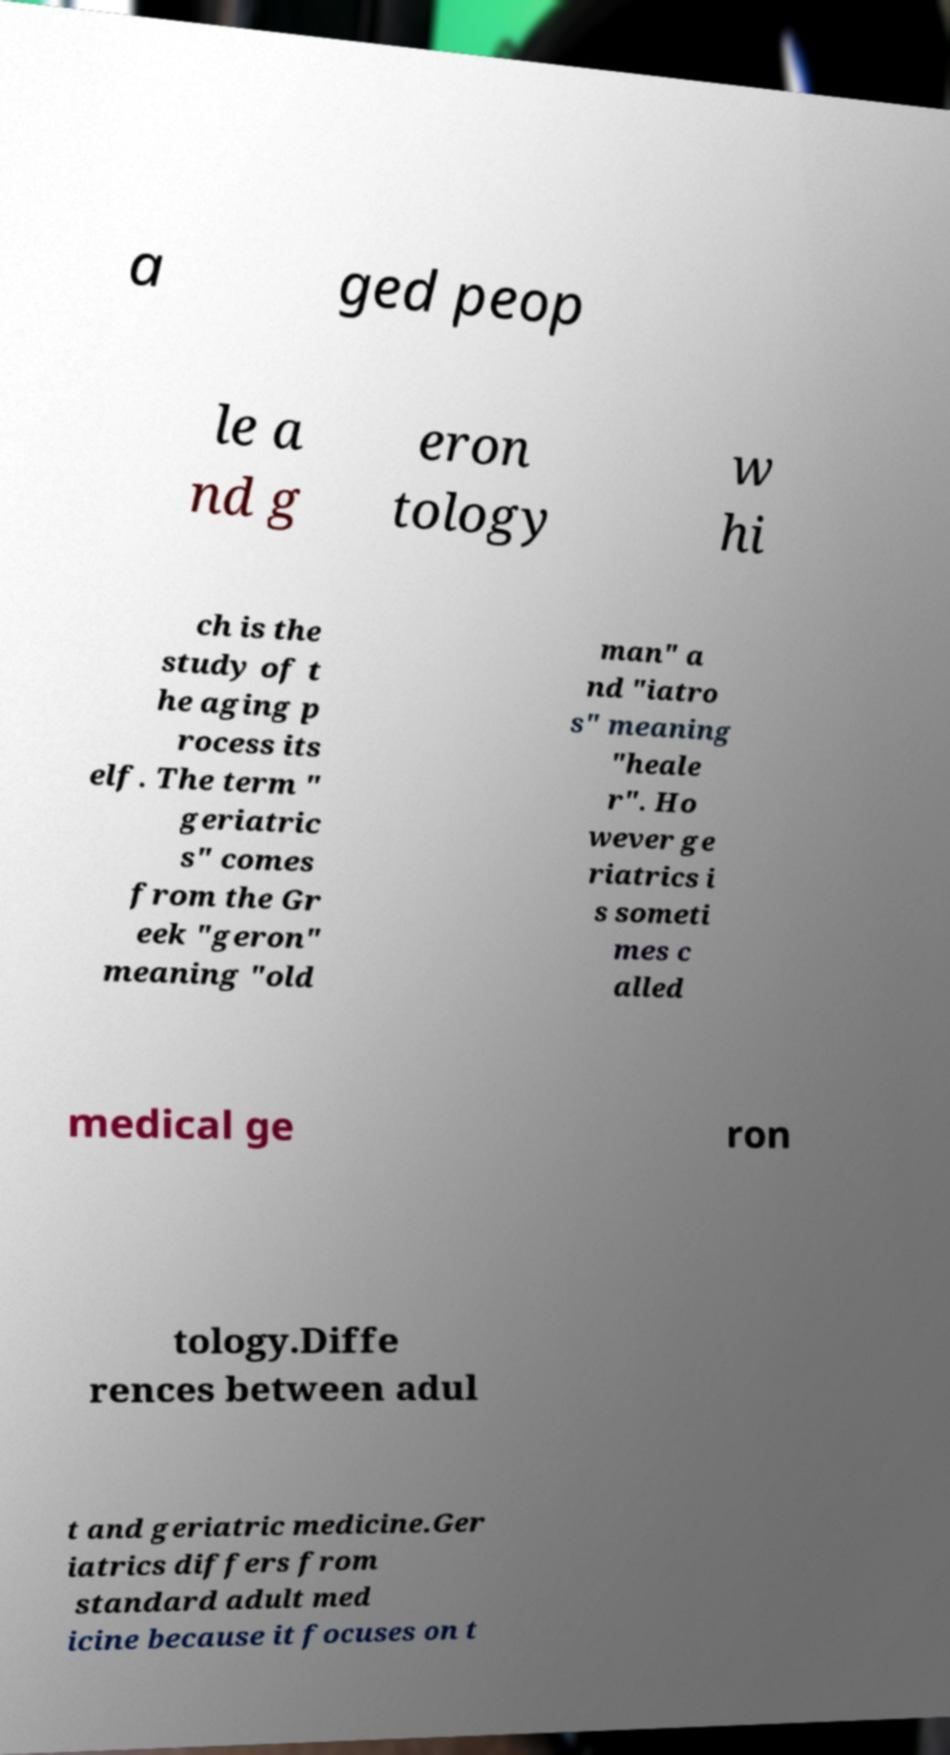Can you read and provide the text displayed in the image?This photo seems to have some interesting text. Can you extract and type it out for me? a ged peop le a nd g eron tology w hi ch is the study of t he aging p rocess its elf. The term " geriatric s" comes from the Gr eek "geron" meaning "old man" a nd "iatro s" meaning "heale r". Ho wever ge riatrics i s someti mes c alled medical ge ron tology.Diffe rences between adul t and geriatric medicine.Ger iatrics differs from standard adult med icine because it focuses on t 